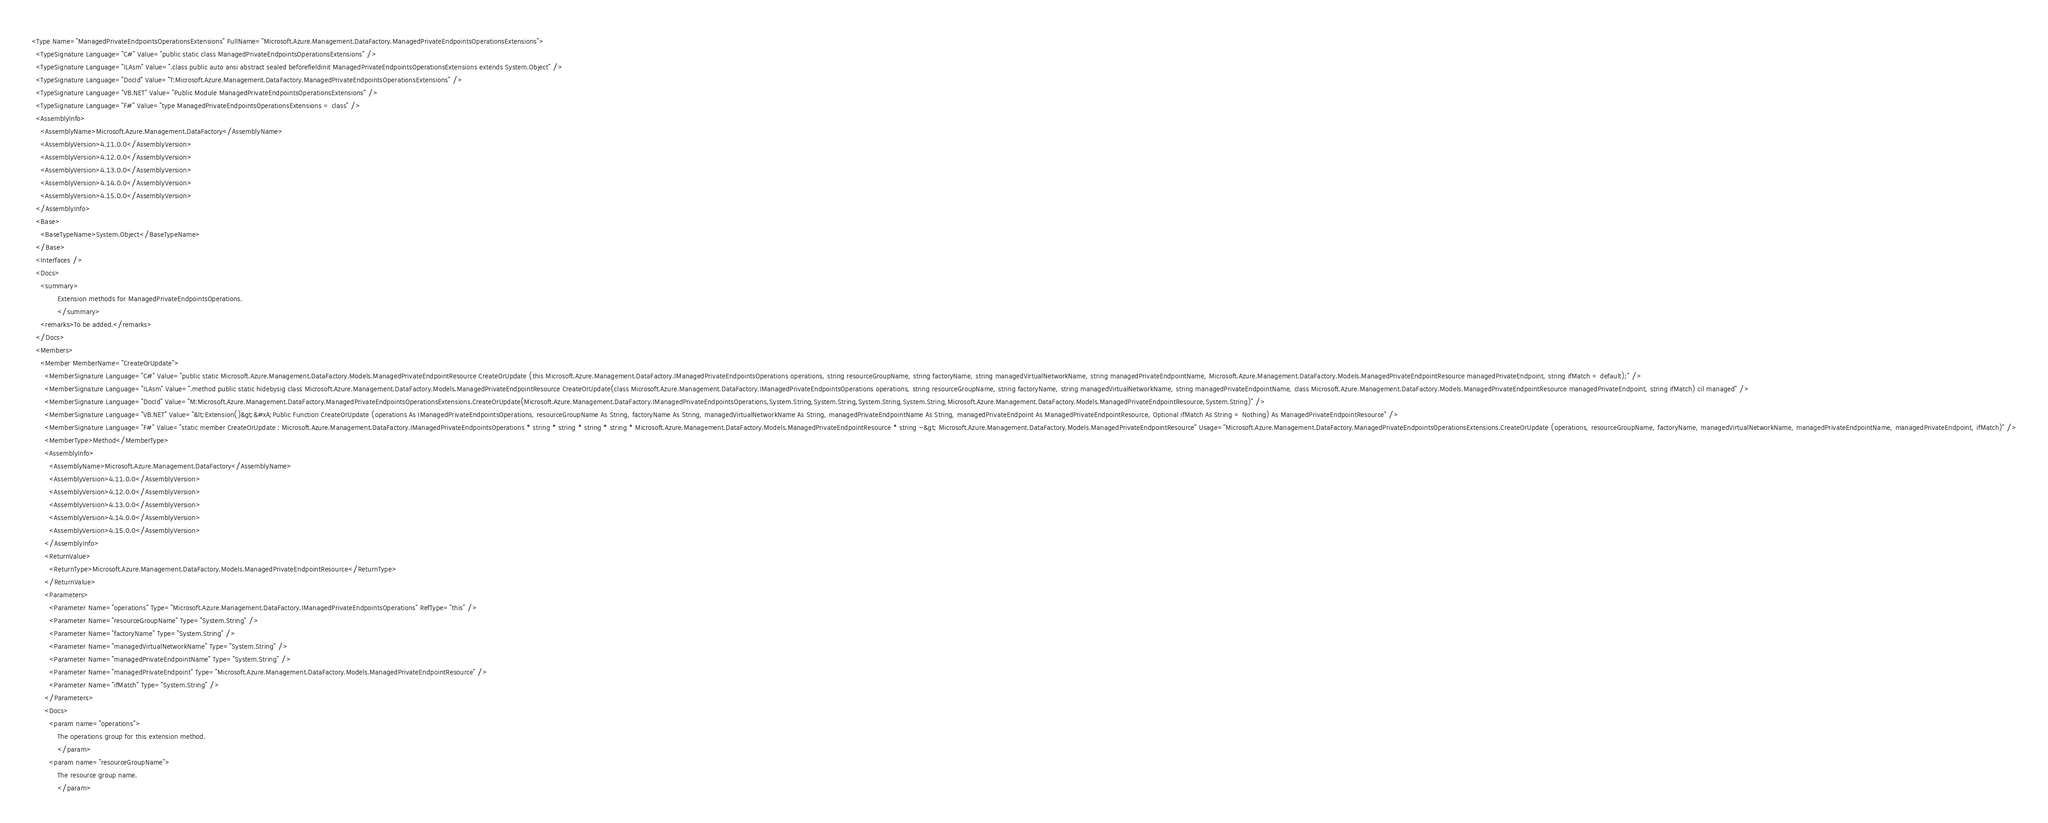Convert code to text. <code><loc_0><loc_0><loc_500><loc_500><_XML_><Type Name="ManagedPrivateEndpointsOperationsExtensions" FullName="Microsoft.Azure.Management.DataFactory.ManagedPrivateEndpointsOperationsExtensions">
  <TypeSignature Language="C#" Value="public static class ManagedPrivateEndpointsOperationsExtensions" />
  <TypeSignature Language="ILAsm" Value=".class public auto ansi abstract sealed beforefieldinit ManagedPrivateEndpointsOperationsExtensions extends System.Object" />
  <TypeSignature Language="DocId" Value="T:Microsoft.Azure.Management.DataFactory.ManagedPrivateEndpointsOperationsExtensions" />
  <TypeSignature Language="VB.NET" Value="Public Module ManagedPrivateEndpointsOperationsExtensions" />
  <TypeSignature Language="F#" Value="type ManagedPrivateEndpointsOperationsExtensions = class" />
  <AssemblyInfo>
    <AssemblyName>Microsoft.Azure.Management.DataFactory</AssemblyName>
    <AssemblyVersion>4.11.0.0</AssemblyVersion>
    <AssemblyVersion>4.12.0.0</AssemblyVersion>
    <AssemblyVersion>4.13.0.0</AssemblyVersion>
    <AssemblyVersion>4.14.0.0</AssemblyVersion>
    <AssemblyVersion>4.15.0.0</AssemblyVersion>
  </AssemblyInfo>
  <Base>
    <BaseTypeName>System.Object</BaseTypeName>
  </Base>
  <Interfaces />
  <Docs>
    <summary>
            Extension methods for ManagedPrivateEndpointsOperations.
            </summary>
    <remarks>To be added.</remarks>
  </Docs>
  <Members>
    <Member MemberName="CreateOrUpdate">
      <MemberSignature Language="C#" Value="public static Microsoft.Azure.Management.DataFactory.Models.ManagedPrivateEndpointResource CreateOrUpdate (this Microsoft.Azure.Management.DataFactory.IManagedPrivateEndpointsOperations operations, string resourceGroupName, string factoryName, string managedVirtualNetworkName, string managedPrivateEndpointName, Microsoft.Azure.Management.DataFactory.Models.ManagedPrivateEndpointResource managedPrivateEndpoint, string ifMatch = default);" />
      <MemberSignature Language="ILAsm" Value=".method public static hidebysig class Microsoft.Azure.Management.DataFactory.Models.ManagedPrivateEndpointResource CreateOrUpdate(class Microsoft.Azure.Management.DataFactory.IManagedPrivateEndpointsOperations operations, string resourceGroupName, string factoryName, string managedVirtualNetworkName, string managedPrivateEndpointName, class Microsoft.Azure.Management.DataFactory.Models.ManagedPrivateEndpointResource managedPrivateEndpoint, string ifMatch) cil managed" />
      <MemberSignature Language="DocId" Value="M:Microsoft.Azure.Management.DataFactory.ManagedPrivateEndpointsOperationsExtensions.CreateOrUpdate(Microsoft.Azure.Management.DataFactory.IManagedPrivateEndpointsOperations,System.String,System.String,System.String,System.String,Microsoft.Azure.Management.DataFactory.Models.ManagedPrivateEndpointResource,System.String)" />
      <MemberSignature Language="VB.NET" Value="&lt;Extension()&gt;&#xA;Public Function CreateOrUpdate (operations As IManagedPrivateEndpointsOperations, resourceGroupName As String, factoryName As String, managedVirtualNetworkName As String, managedPrivateEndpointName As String, managedPrivateEndpoint As ManagedPrivateEndpointResource, Optional ifMatch As String = Nothing) As ManagedPrivateEndpointResource" />
      <MemberSignature Language="F#" Value="static member CreateOrUpdate : Microsoft.Azure.Management.DataFactory.IManagedPrivateEndpointsOperations * string * string * string * string * Microsoft.Azure.Management.DataFactory.Models.ManagedPrivateEndpointResource * string -&gt; Microsoft.Azure.Management.DataFactory.Models.ManagedPrivateEndpointResource" Usage="Microsoft.Azure.Management.DataFactory.ManagedPrivateEndpointsOperationsExtensions.CreateOrUpdate (operations, resourceGroupName, factoryName, managedVirtualNetworkName, managedPrivateEndpointName, managedPrivateEndpoint, ifMatch)" />
      <MemberType>Method</MemberType>
      <AssemblyInfo>
        <AssemblyName>Microsoft.Azure.Management.DataFactory</AssemblyName>
        <AssemblyVersion>4.11.0.0</AssemblyVersion>
        <AssemblyVersion>4.12.0.0</AssemblyVersion>
        <AssemblyVersion>4.13.0.0</AssemblyVersion>
        <AssemblyVersion>4.14.0.0</AssemblyVersion>
        <AssemblyVersion>4.15.0.0</AssemblyVersion>
      </AssemblyInfo>
      <ReturnValue>
        <ReturnType>Microsoft.Azure.Management.DataFactory.Models.ManagedPrivateEndpointResource</ReturnType>
      </ReturnValue>
      <Parameters>
        <Parameter Name="operations" Type="Microsoft.Azure.Management.DataFactory.IManagedPrivateEndpointsOperations" RefType="this" />
        <Parameter Name="resourceGroupName" Type="System.String" />
        <Parameter Name="factoryName" Type="System.String" />
        <Parameter Name="managedVirtualNetworkName" Type="System.String" />
        <Parameter Name="managedPrivateEndpointName" Type="System.String" />
        <Parameter Name="managedPrivateEndpoint" Type="Microsoft.Azure.Management.DataFactory.Models.ManagedPrivateEndpointResource" />
        <Parameter Name="ifMatch" Type="System.String" />
      </Parameters>
      <Docs>
        <param name="operations">
            The operations group for this extension method.
            </param>
        <param name="resourceGroupName">
            The resource group name.
            </param></code> 